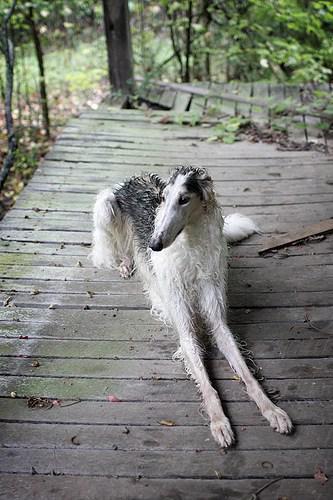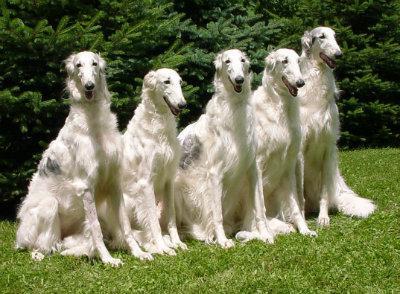The first image is the image on the left, the second image is the image on the right. Given the left and right images, does the statement "All dogs in the images are on the grass." hold true? Answer yes or no. No. 